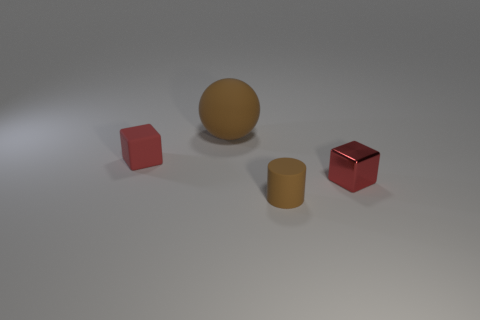What is the material of the red cube that is on the left side of the matte object that is in front of the block behind the small shiny block? rubber 